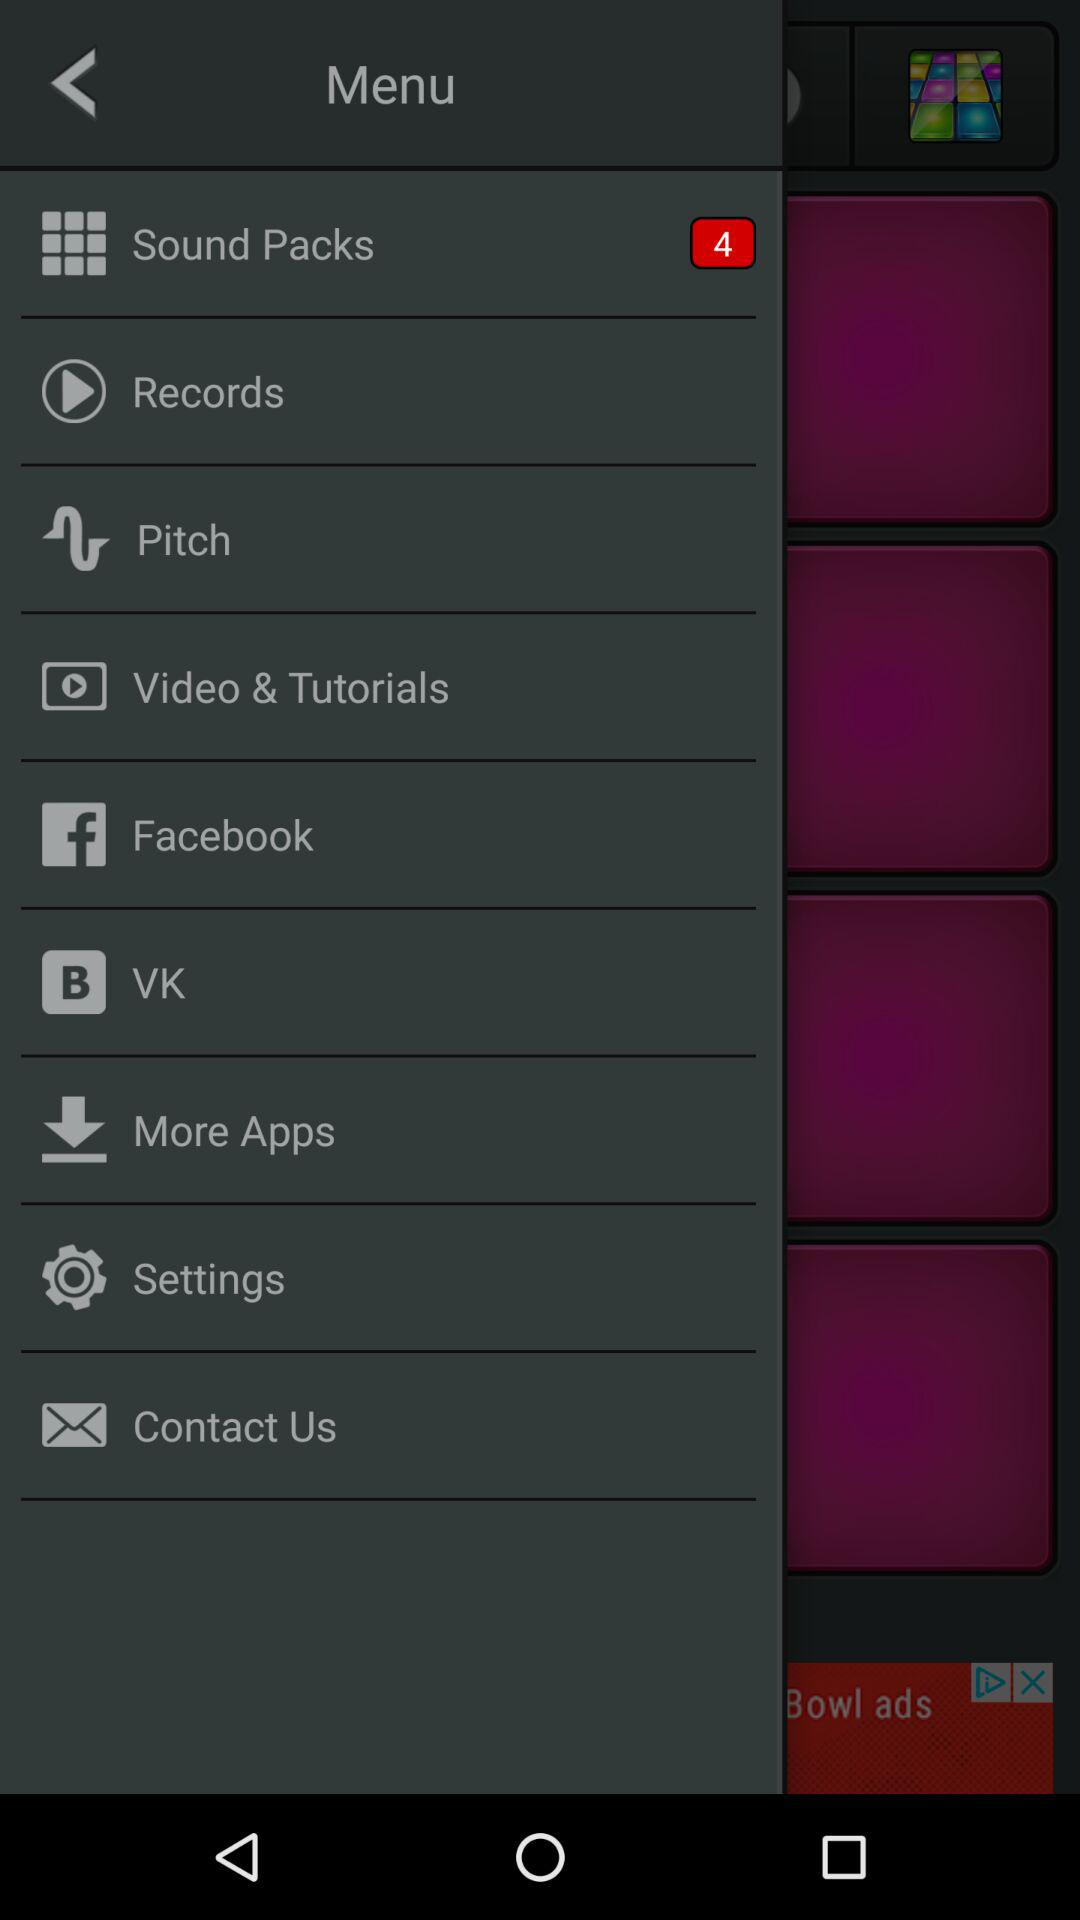What is the number of notifications in Sound Packs? The number of notifications is 4. 